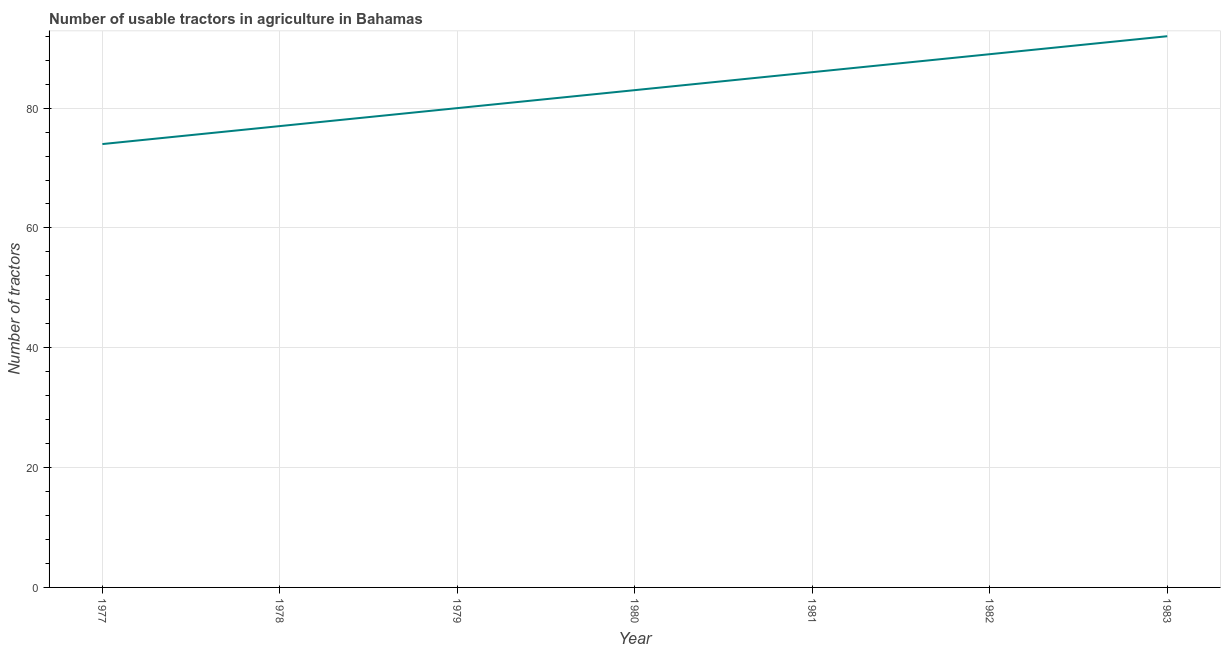What is the number of tractors in 1982?
Your response must be concise. 89. Across all years, what is the maximum number of tractors?
Make the answer very short. 92. Across all years, what is the minimum number of tractors?
Provide a short and direct response. 74. What is the sum of the number of tractors?
Ensure brevity in your answer.  581. What is the difference between the number of tractors in 1979 and 1982?
Provide a succinct answer. -9. What is the average number of tractors per year?
Your answer should be very brief. 83. In how many years, is the number of tractors greater than 48 ?
Your answer should be very brief. 7. What is the ratio of the number of tractors in 1980 to that in 1982?
Keep it short and to the point. 0.93. Is the difference between the number of tractors in 1977 and 1983 greater than the difference between any two years?
Your answer should be compact. Yes. What is the difference between the highest and the second highest number of tractors?
Provide a short and direct response. 3. Is the sum of the number of tractors in 1977 and 1981 greater than the maximum number of tractors across all years?
Offer a terse response. Yes. What is the difference between the highest and the lowest number of tractors?
Give a very brief answer. 18. Does the number of tractors monotonically increase over the years?
Make the answer very short. Yes. How many lines are there?
Offer a very short reply. 1. Are the values on the major ticks of Y-axis written in scientific E-notation?
Offer a terse response. No. Does the graph contain any zero values?
Provide a short and direct response. No. What is the title of the graph?
Your answer should be compact. Number of usable tractors in agriculture in Bahamas. What is the label or title of the X-axis?
Keep it short and to the point. Year. What is the label or title of the Y-axis?
Ensure brevity in your answer.  Number of tractors. What is the Number of tractors of 1977?
Offer a very short reply. 74. What is the Number of tractors of 1979?
Your answer should be very brief. 80. What is the Number of tractors in 1981?
Your response must be concise. 86. What is the Number of tractors of 1982?
Keep it short and to the point. 89. What is the Number of tractors in 1983?
Your answer should be compact. 92. What is the difference between the Number of tractors in 1977 and 1979?
Ensure brevity in your answer.  -6. What is the difference between the Number of tractors in 1977 and 1982?
Your answer should be compact. -15. What is the difference between the Number of tractors in 1977 and 1983?
Keep it short and to the point. -18. What is the difference between the Number of tractors in 1978 and 1980?
Make the answer very short. -6. What is the difference between the Number of tractors in 1978 and 1981?
Offer a very short reply. -9. What is the difference between the Number of tractors in 1978 and 1982?
Offer a very short reply. -12. What is the difference between the Number of tractors in 1979 and 1981?
Give a very brief answer. -6. What is the difference between the Number of tractors in 1979 and 1982?
Provide a short and direct response. -9. What is the difference between the Number of tractors in 1980 and 1981?
Make the answer very short. -3. What is the difference between the Number of tractors in 1980 and 1983?
Offer a very short reply. -9. What is the difference between the Number of tractors in 1981 and 1982?
Ensure brevity in your answer.  -3. What is the difference between the Number of tractors in 1981 and 1983?
Provide a succinct answer. -6. What is the ratio of the Number of tractors in 1977 to that in 1979?
Make the answer very short. 0.93. What is the ratio of the Number of tractors in 1977 to that in 1980?
Your response must be concise. 0.89. What is the ratio of the Number of tractors in 1977 to that in 1981?
Ensure brevity in your answer.  0.86. What is the ratio of the Number of tractors in 1977 to that in 1982?
Your response must be concise. 0.83. What is the ratio of the Number of tractors in 1977 to that in 1983?
Give a very brief answer. 0.8. What is the ratio of the Number of tractors in 1978 to that in 1979?
Provide a succinct answer. 0.96. What is the ratio of the Number of tractors in 1978 to that in 1980?
Offer a terse response. 0.93. What is the ratio of the Number of tractors in 1978 to that in 1981?
Make the answer very short. 0.9. What is the ratio of the Number of tractors in 1978 to that in 1982?
Make the answer very short. 0.86. What is the ratio of the Number of tractors in 1978 to that in 1983?
Keep it short and to the point. 0.84. What is the ratio of the Number of tractors in 1979 to that in 1980?
Offer a very short reply. 0.96. What is the ratio of the Number of tractors in 1979 to that in 1981?
Provide a short and direct response. 0.93. What is the ratio of the Number of tractors in 1979 to that in 1982?
Your response must be concise. 0.9. What is the ratio of the Number of tractors in 1979 to that in 1983?
Ensure brevity in your answer.  0.87. What is the ratio of the Number of tractors in 1980 to that in 1981?
Your response must be concise. 0.96. What is the ratio of the Number of tractors in 1980 to that in 1982?
Give a very brief answer. 0.93. What is the ratio of the Number of tractors in 1980 to that in 1983?
Your answer should be very brief. 0.9. What is the ratio of the Number of tractors in 1981 to that in 1983?
Your response must be concise. 0.94. What is the ratio of the Number of tractors in 1982 to that in 1983?
Provide a short and direct response. 0.97. 